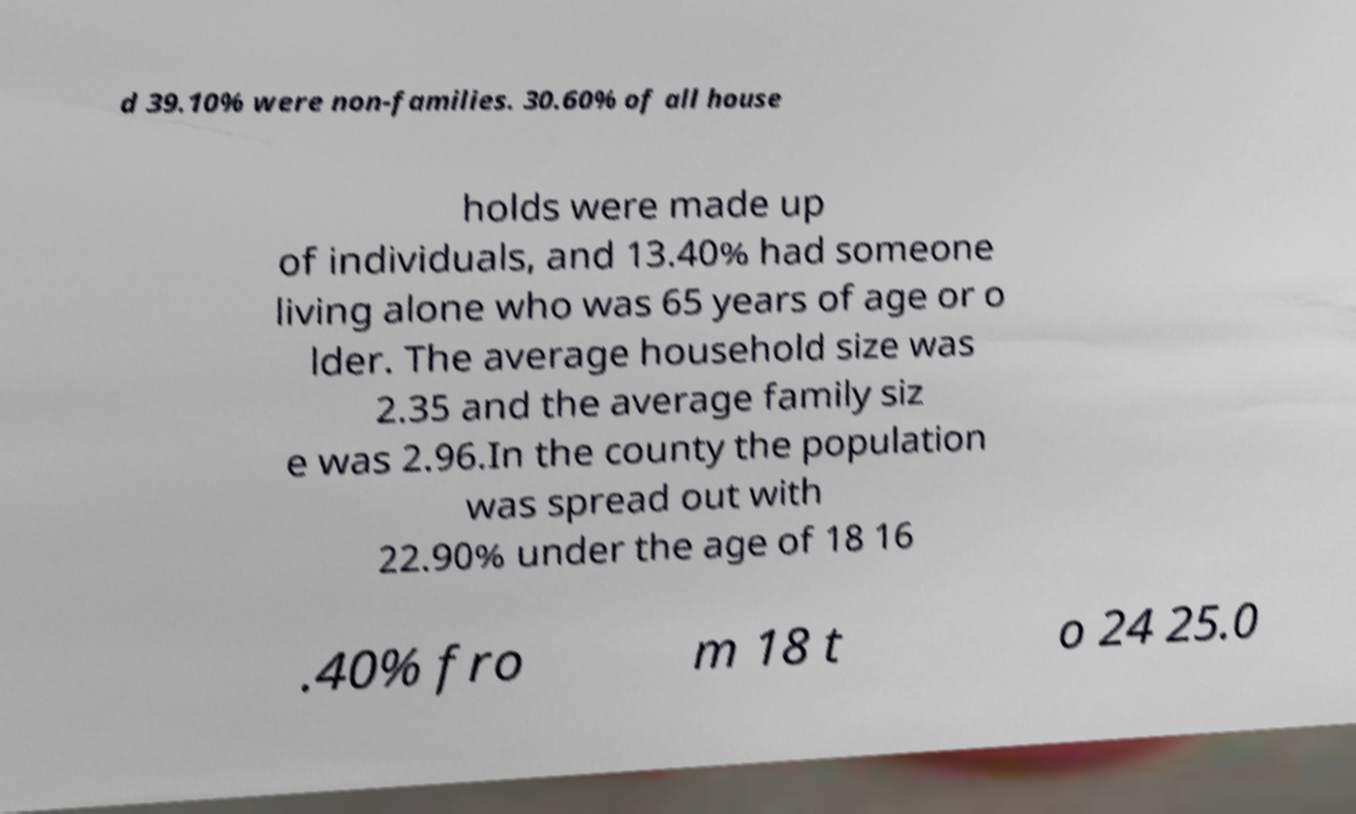Please identify and transcribe the text found in this image. d 39.10% were non-families. 30.60% of all house holds were made up of individuals, and 13.40% had someone living alone who was 65 years of age or o lder. The average household size was 2.35 and the average family siz e was 2.96.In the county the population was spread out with 22.90% under the age of 18 16 .40% fro m 18 t o 24 25.0 